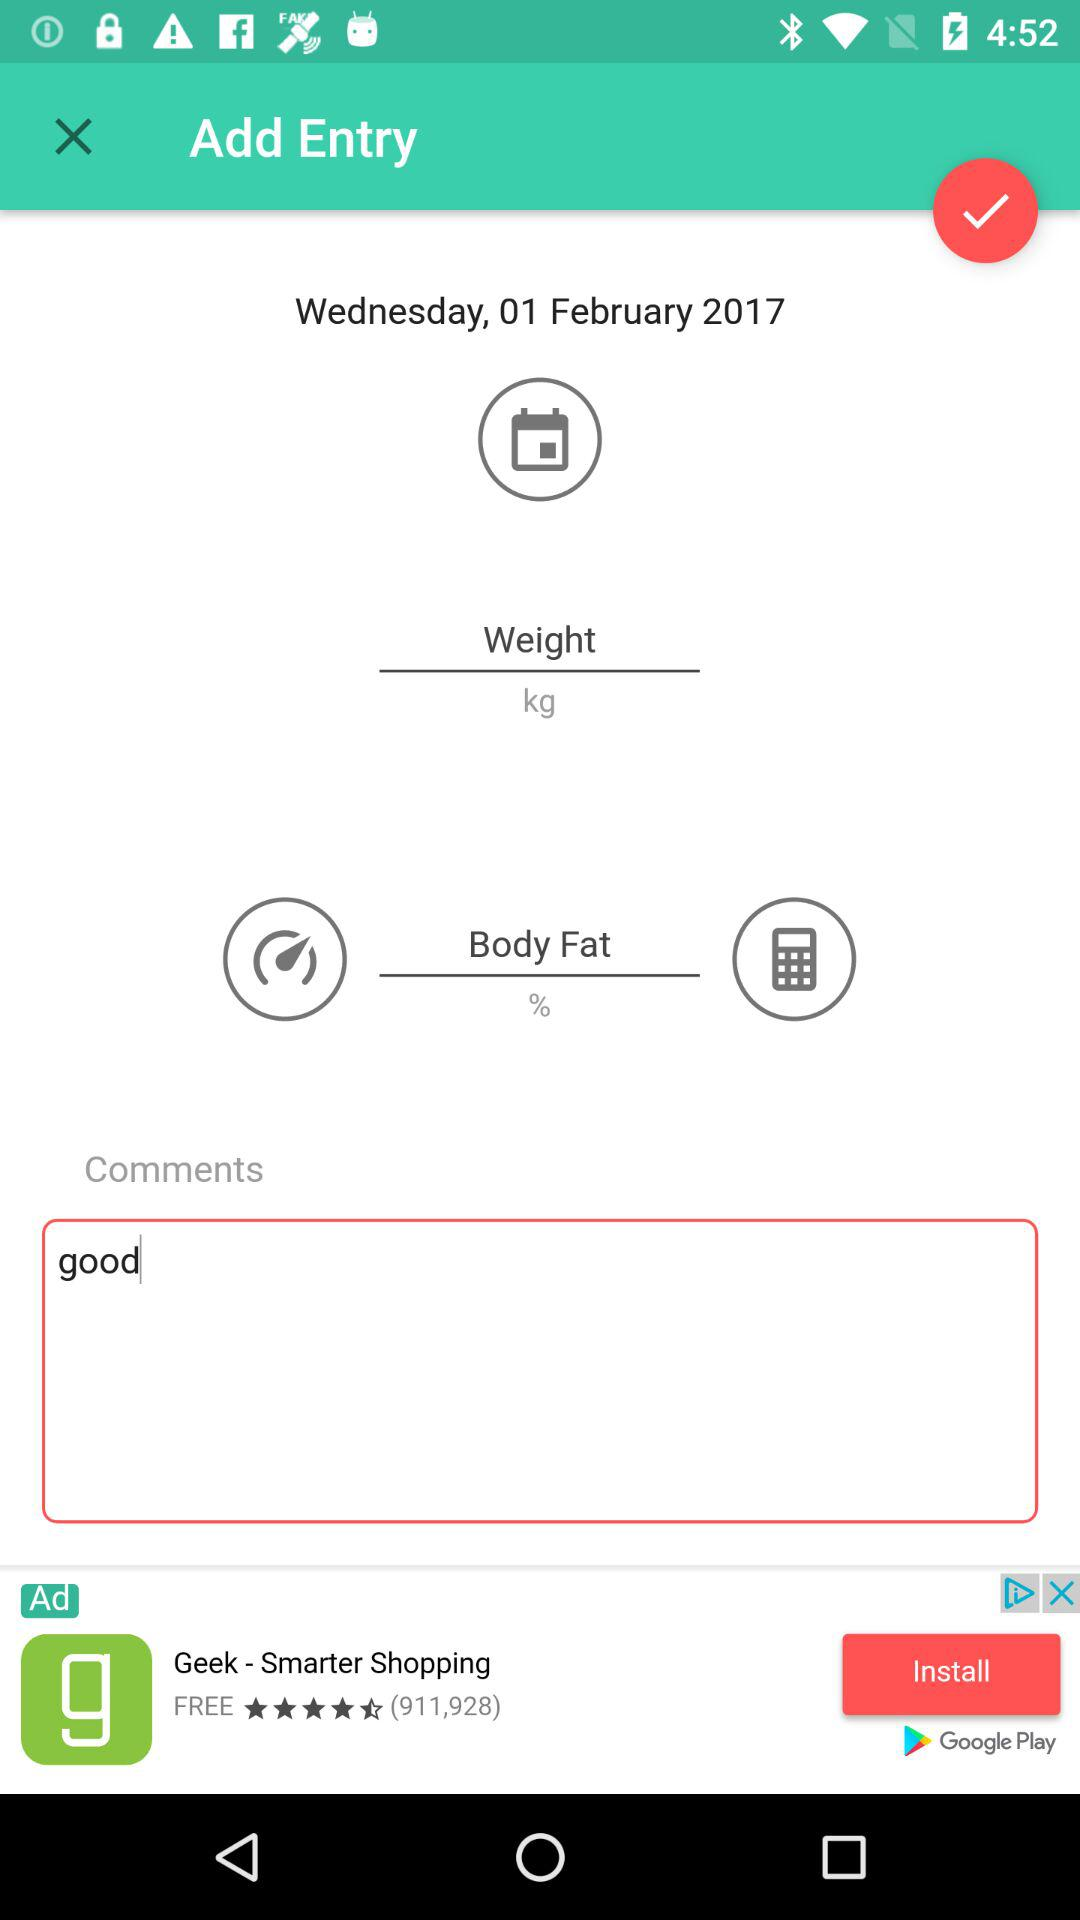What is the given date? The date is Wednesday, 1 February 2017. 